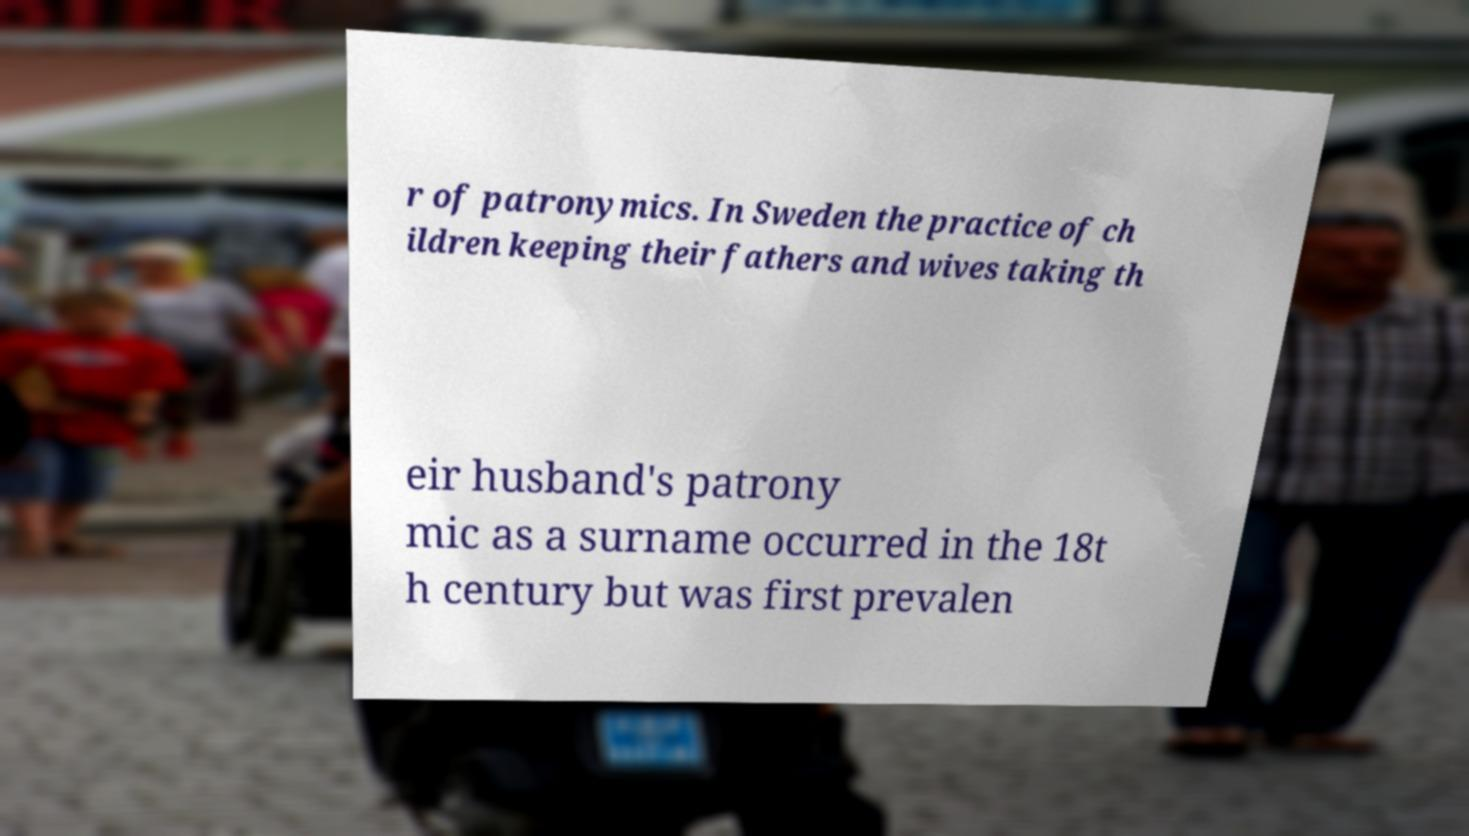Could you extract and type out the text from this image? r of patronymics. In Sweden the practice of ch ildren keeping their fathers and wives taking th eir husband's patrony mic as a surname occurred in the 18t h century but was first prevalen 